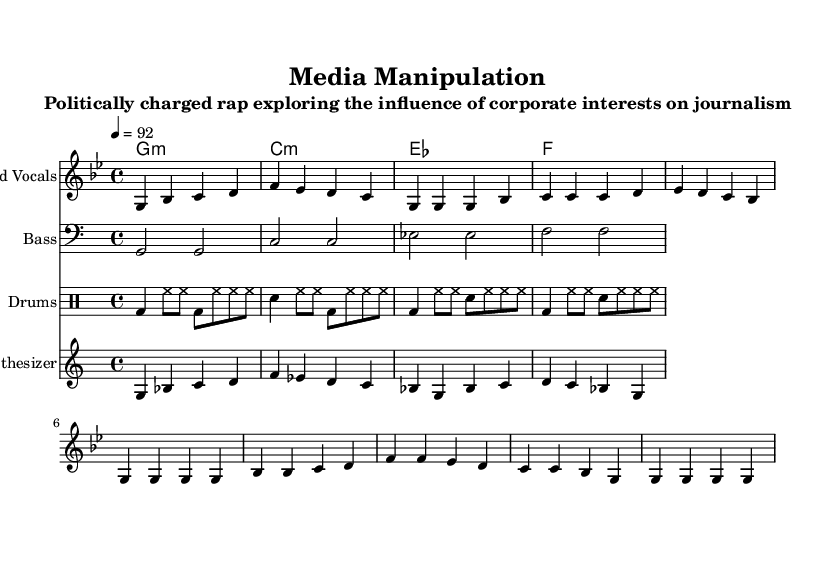What is the key signature of this music? The key signature indicated is G minor, which has two flats (B flat and E flat). This can be determined by observing the two flat symbols at the beginning of the staff.
Answer: G minor What is the time signature of this music? The time signature is 4/4, as noted at the beginning of the score. This indicates that there are four beats in each measure.
Answer: 4/4 What is the tempo marking for this piece? The tempo marking is noted as 92 beats per minute; this is indicated by the "4 = 92" at the beginning.
Answer: 92 How many distinct sections are present in the melody? The melody consists of two distinct sections: the intro and the verse, followed by a chorus. This can be identified by looking at the different groupings and transitions in the melody portion.
Answer: Three What types of instruments are used in this piece? The piece uses four types of instruments: vocals, bass, drums, and synthesizer. The types are indicated by the names of the staves present in the score.
Answer: Vocals, Bass, Drums, Synthesizer Describe the rhythmic pattern of the drum part. The drum part features a combination of bass drum (bd), snare drum (sn), and hi-hats (hh) in a repeating pattern, with variations across measures that create a consistent hip hop beat. This is visible in the structured notation of the drummode section.
Answer: Hip hop beat What is the role of the synthesizer in this piece? The synthesizer in this piece serves to enhance the melody with additional harmonic texture, which can be observed from the additional melodic line that accompanies the lead vocals in an uplifting manner.
Answer: Harmonic texture 